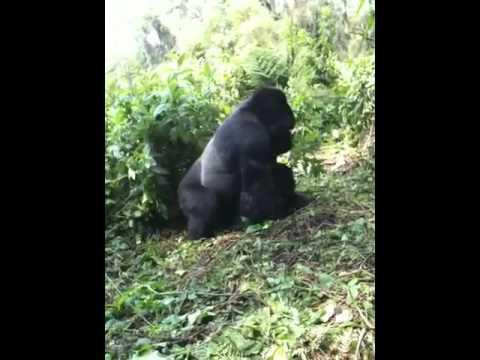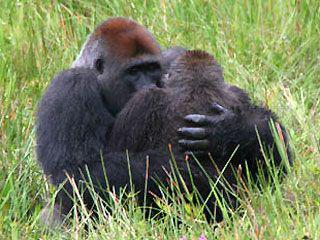The first image is the image on the left, the second image is the image on the right. Considering the images on both sides, is "There is a single male ape not looking at the camera." valid? Answer yes or no. Yes. 